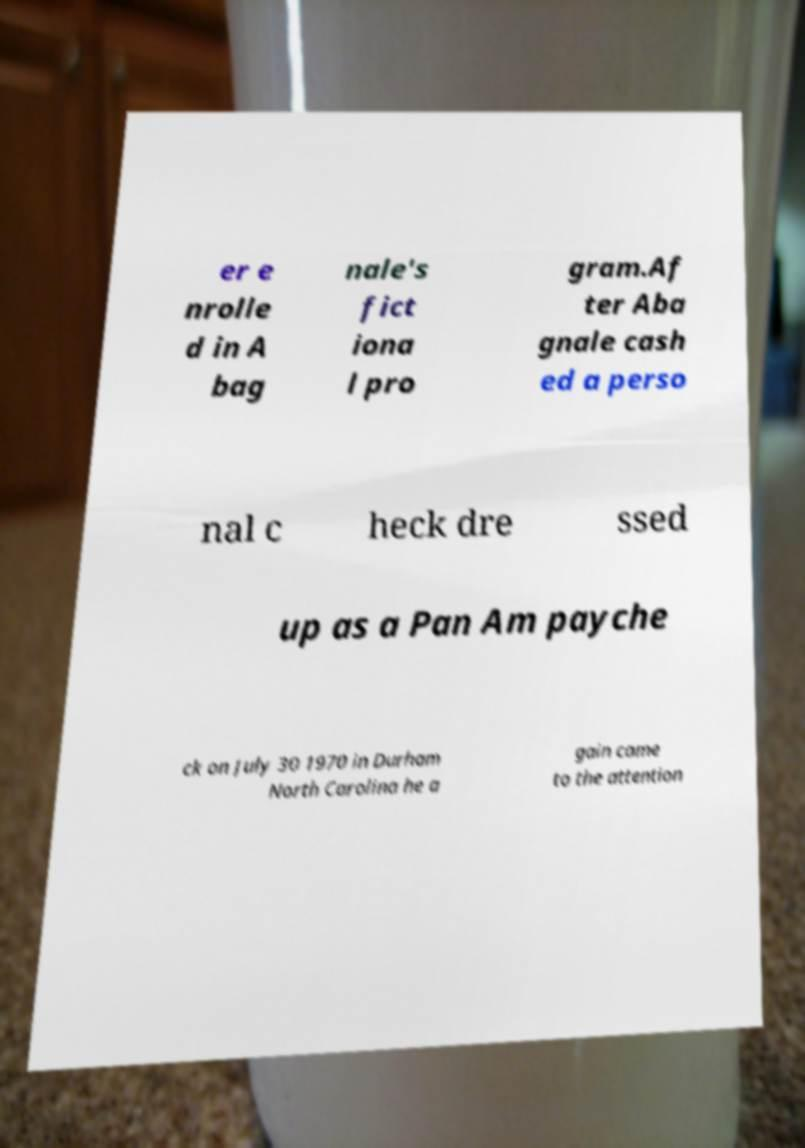Please read and relay the text visible in this image. What does it say? er e nrolle d in A bag nale's fict iona l pro gram.Af ter Aba gnale cash ed a perso nal c heck dre ssed up as a Pan Am payche ck on July 30 1970 in Durham North Carolina he a gain came to the attention 